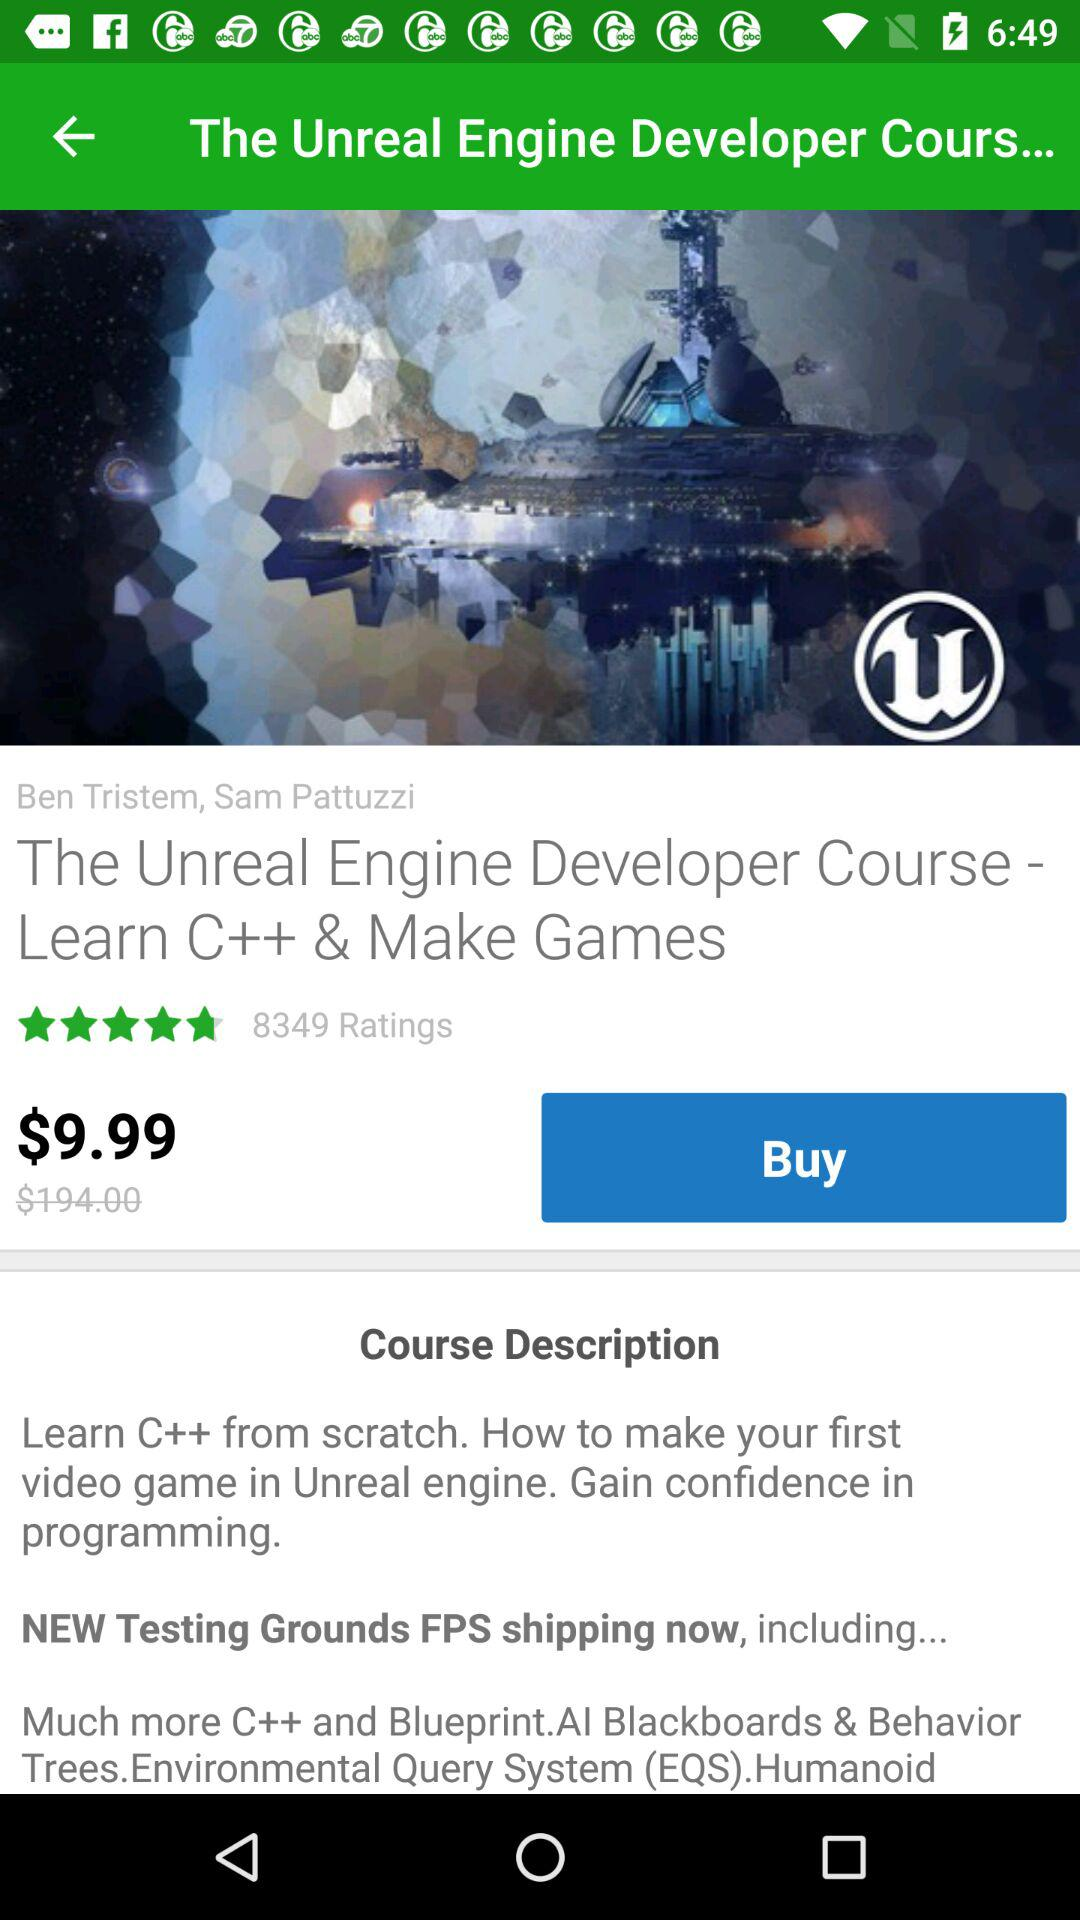What is the course name? The course name is "The Unreal Engine Developer Course - Learn C++ & Make Games". 